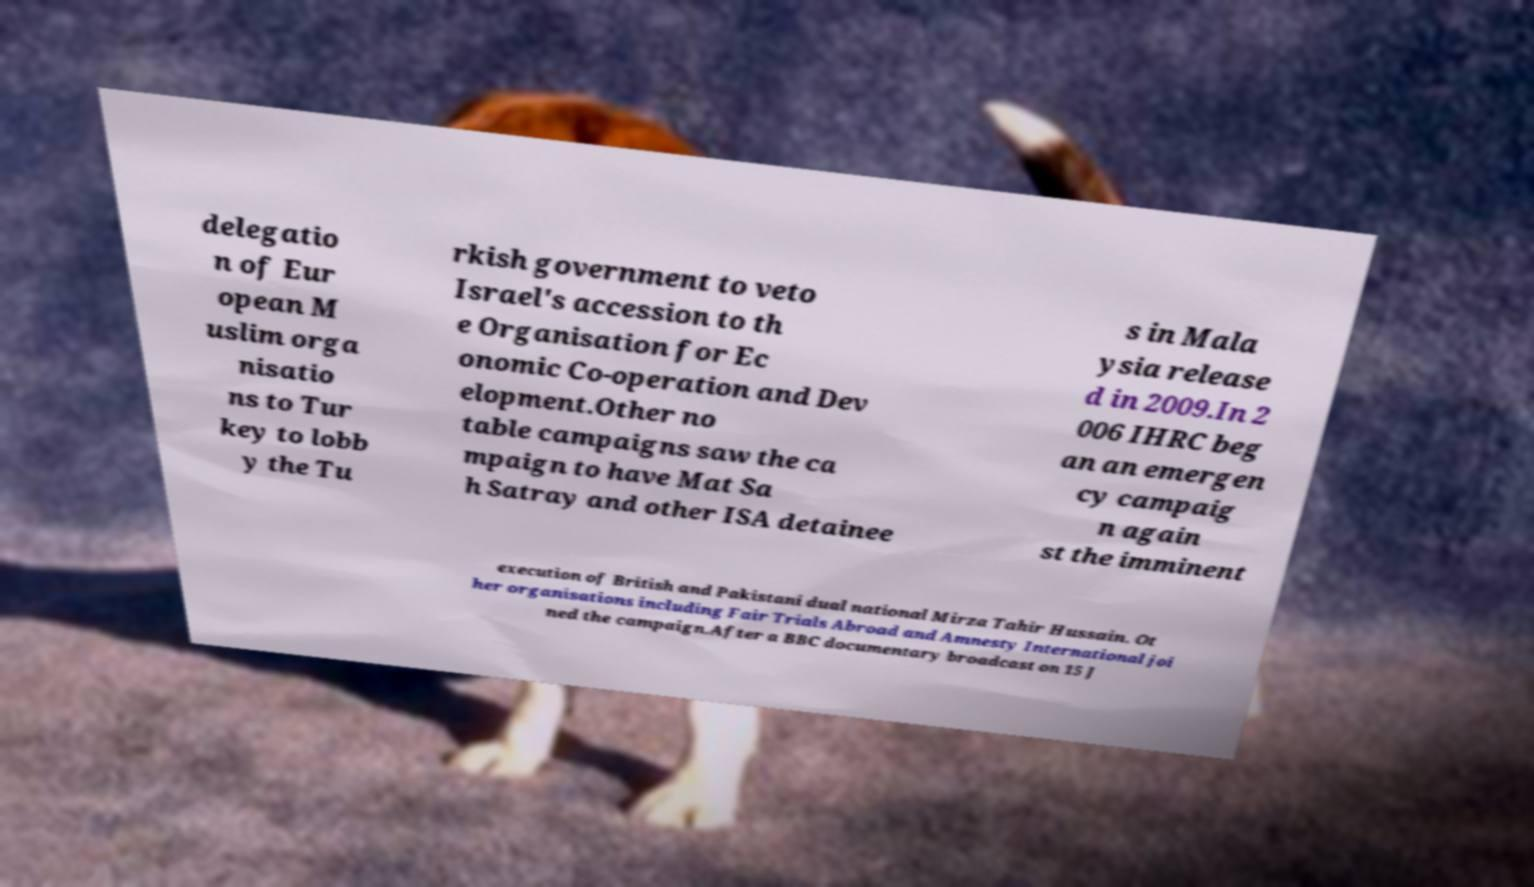I need the written content from this picture converted into text. Can you do that? delegatio n of Eur opean M uslim orga nisatio ns to Tur key to lobb y the Tu rkish government to veto Israel's accession to th e Organisation for Ec onomic Co-operation and Dev elopment.Other no table campaigns saw the ca mpaign to have Mat Sa h Satray and other ISA detainee s in Mala ysia release d in 2009.In 2 006 IHRC beg an an emergen cy campaig n again st the imminent execution of British and Pakistani dual national Mirza Tahir Hussain. Ot her organisations including Fair Trials Abroad and Amnesty International joi ned the campaign.After a BBC documentary broadcast on 15 J 